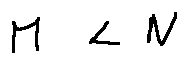Convert formula to latex. <formula><loc_0><loc_0><loc_500><loc_500>M < N</formula> 